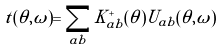Convert formula to latex. <formula><loc_0><loc_0><loc_500><loc_500>t ( \theta , \tilde { \omega } ) = \sum _ { a b } K ^ { + } _ { a b } ( \theta ) U _ { a b } ( \theta , \tilde { \omega } )</formula> 